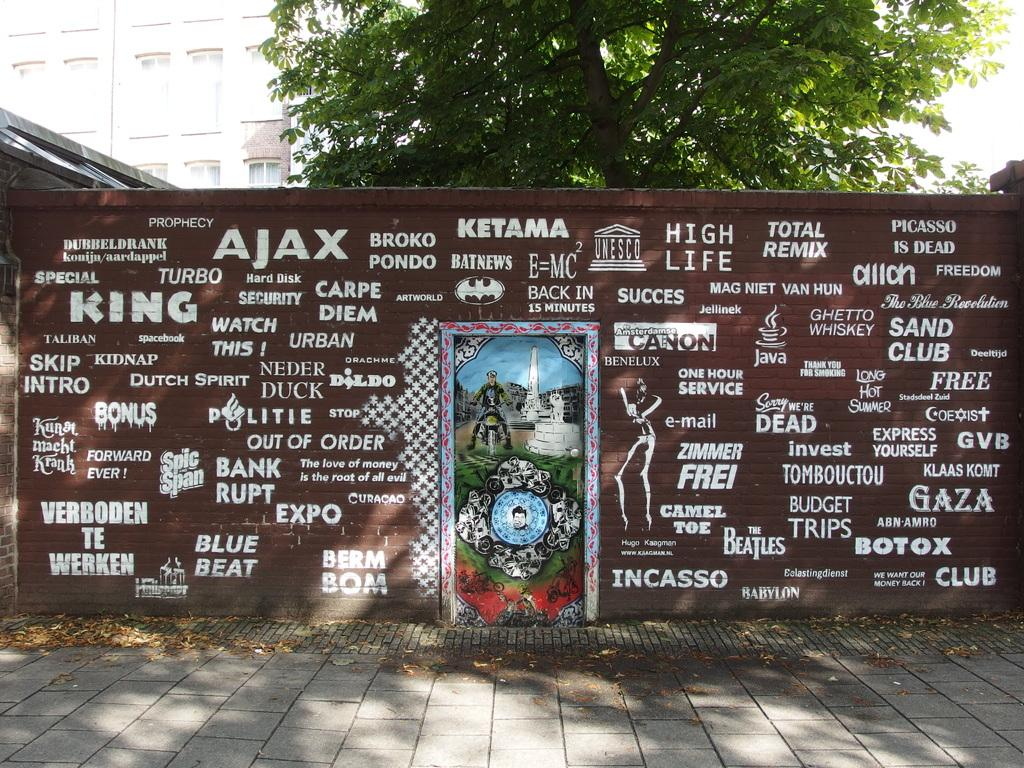What is present on the wall in the image? Something is painted on the wall in the image. What can be seen in the background of the image? There are trees and a building in the background of the image. What historical organization is responsible for the painting on the wall in the image? There is no information about the painting's origin or any historical organization in the image. 